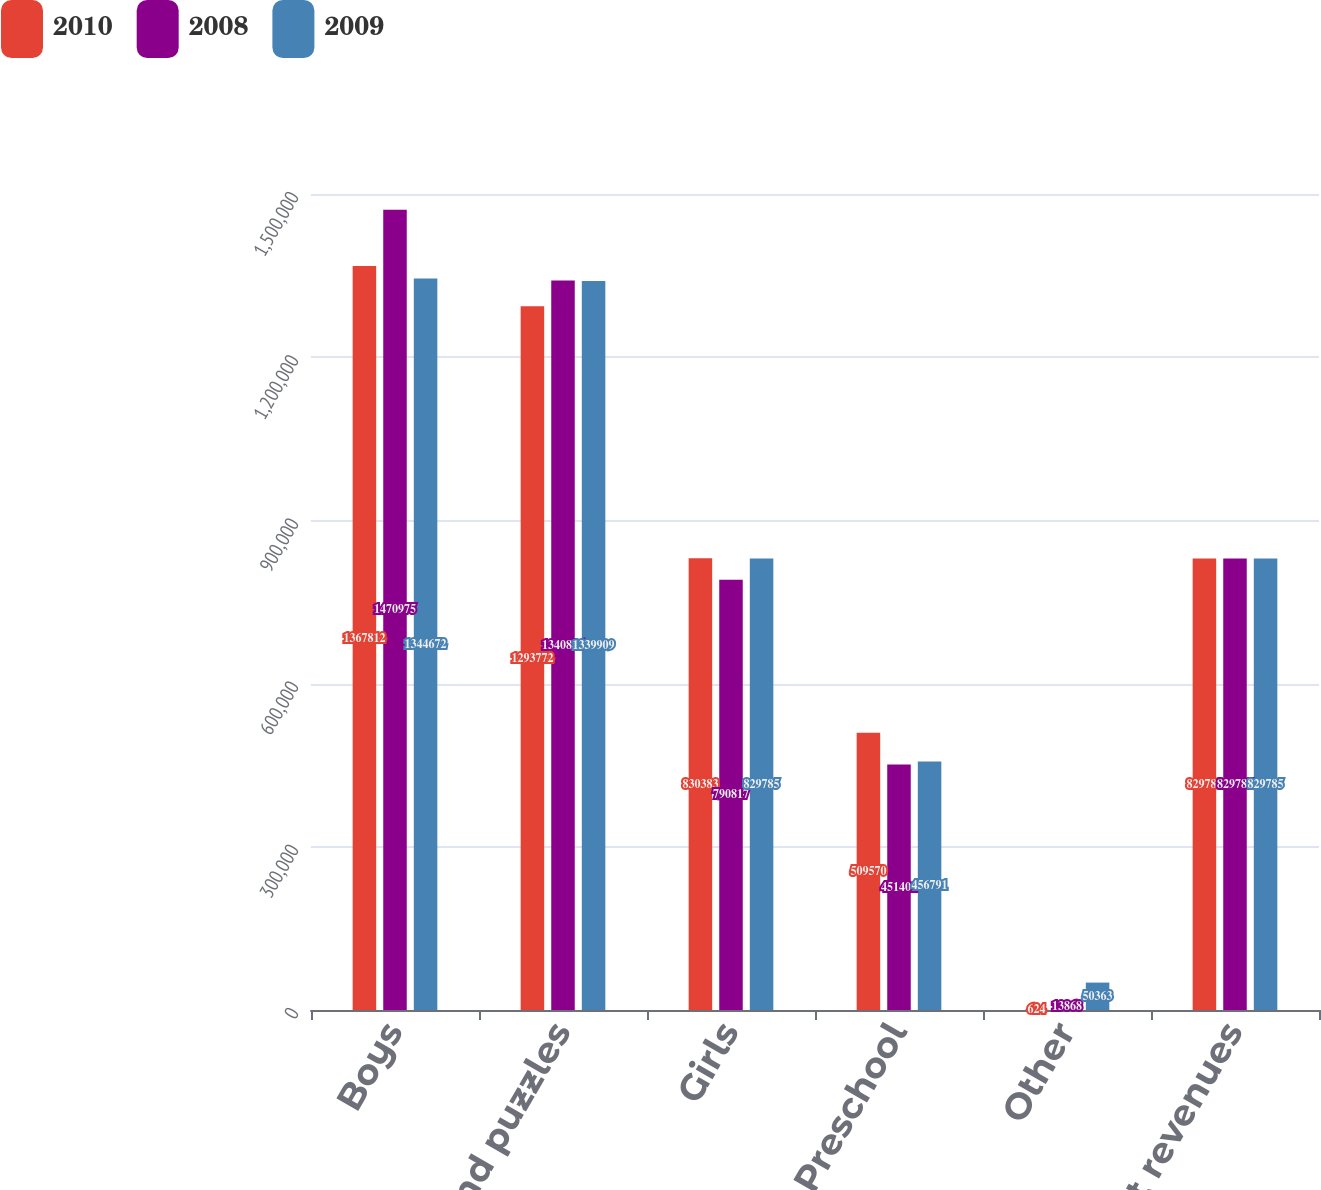Convert chart to OTSL. <chart><loc_0><loc_0><loc_500><loc_500><stacked_bar_chart><ecel><fcel>Boys<fcel>Games and puzzles<fcel>Girls<fcel>Preschool<fcel>Other<fcel>Net revenues<nl><fcel>2010<fcel>1.36781e+06<fcel>1.29377e+06<fcel>830383<fcel>509570<fcel>624<fcel>829785<nl><fcel>2008<fcel>1.47098e+06<fcel>1.34089e+06<fcel>790817<fcel>451401<fcel>13868<fcel>829785<nl><fcel>2009<fcel>1.34467e+06<fcel>1.33991e+06<fcel>829785<fcel>456791<fcel>50363<fcel>829785<nl></chart> 